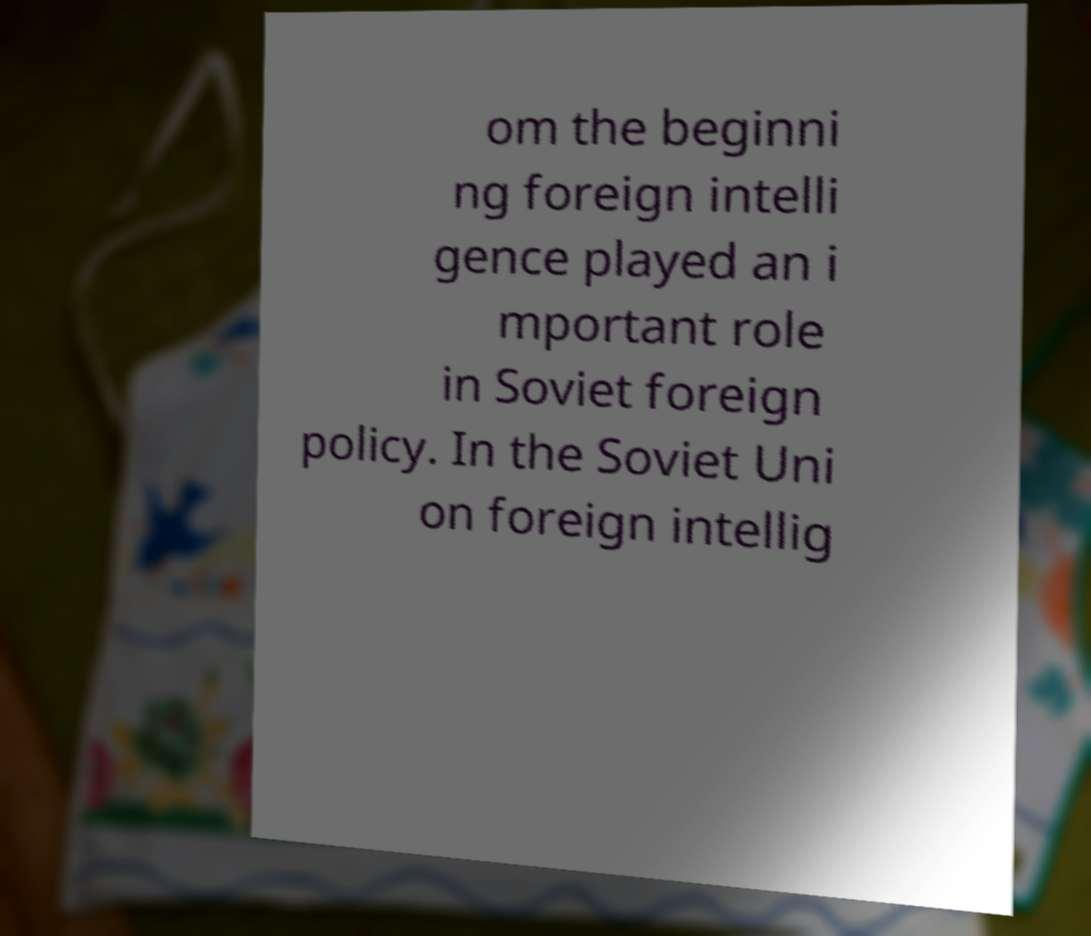Please identify and transcribe the text found in this image. om the beginni ng foreign intelli gence played an i mportant role in Soviet foreign policy. In the Soviet Uni on foreign intellig 